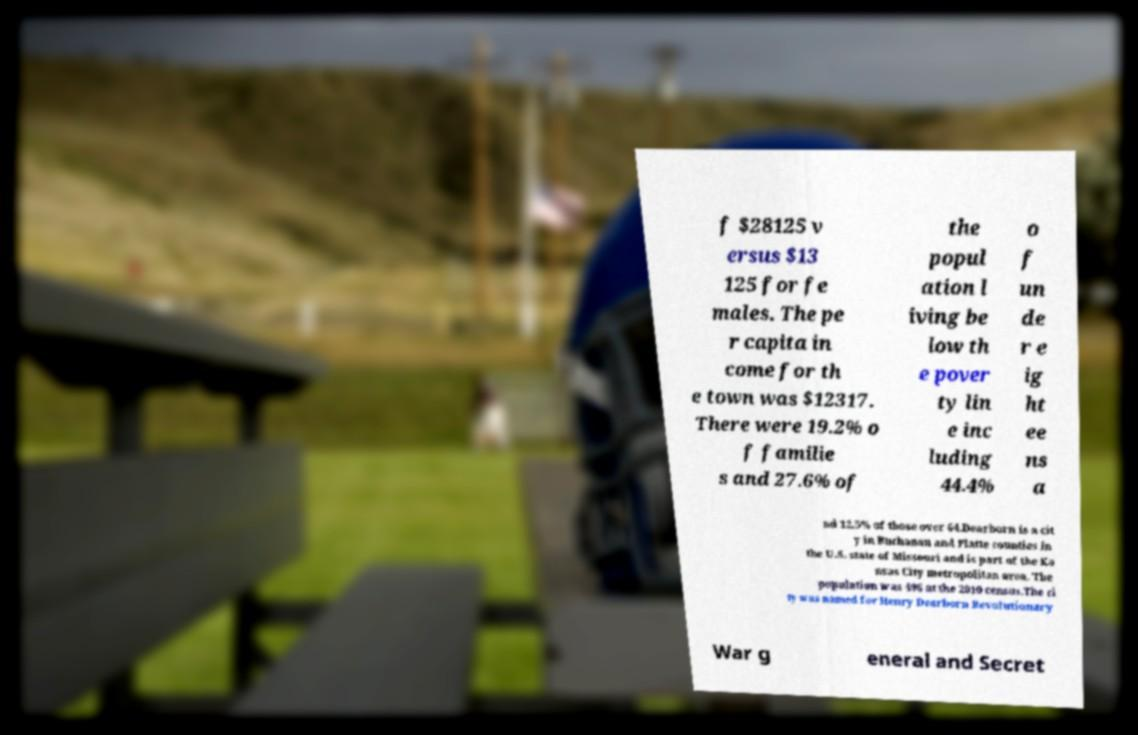Can you read and provide the text displayed in the image?This photo seems to have some interesting text. Can you extract and type it out for me? f $28125 v ersus $13 125 for fe males. The pe r capita in come for th e town was $12317. There were 19.2% o f familie s and 27.6% of the popul ation l iving be low th e pover ty lin e inc luding 44.4% o f un de r e ig ht ee ns a nd 12.5% of those over 64.Dearborn is a cit y in Buchanan and Platte counties in the U.S. state of Missouri and is part of the Ka nsas City metropolitan area. The population was 496 at the 2010 census.The ci ty was named for Henry Dearborn Revolutionary War g eneral and Secret 